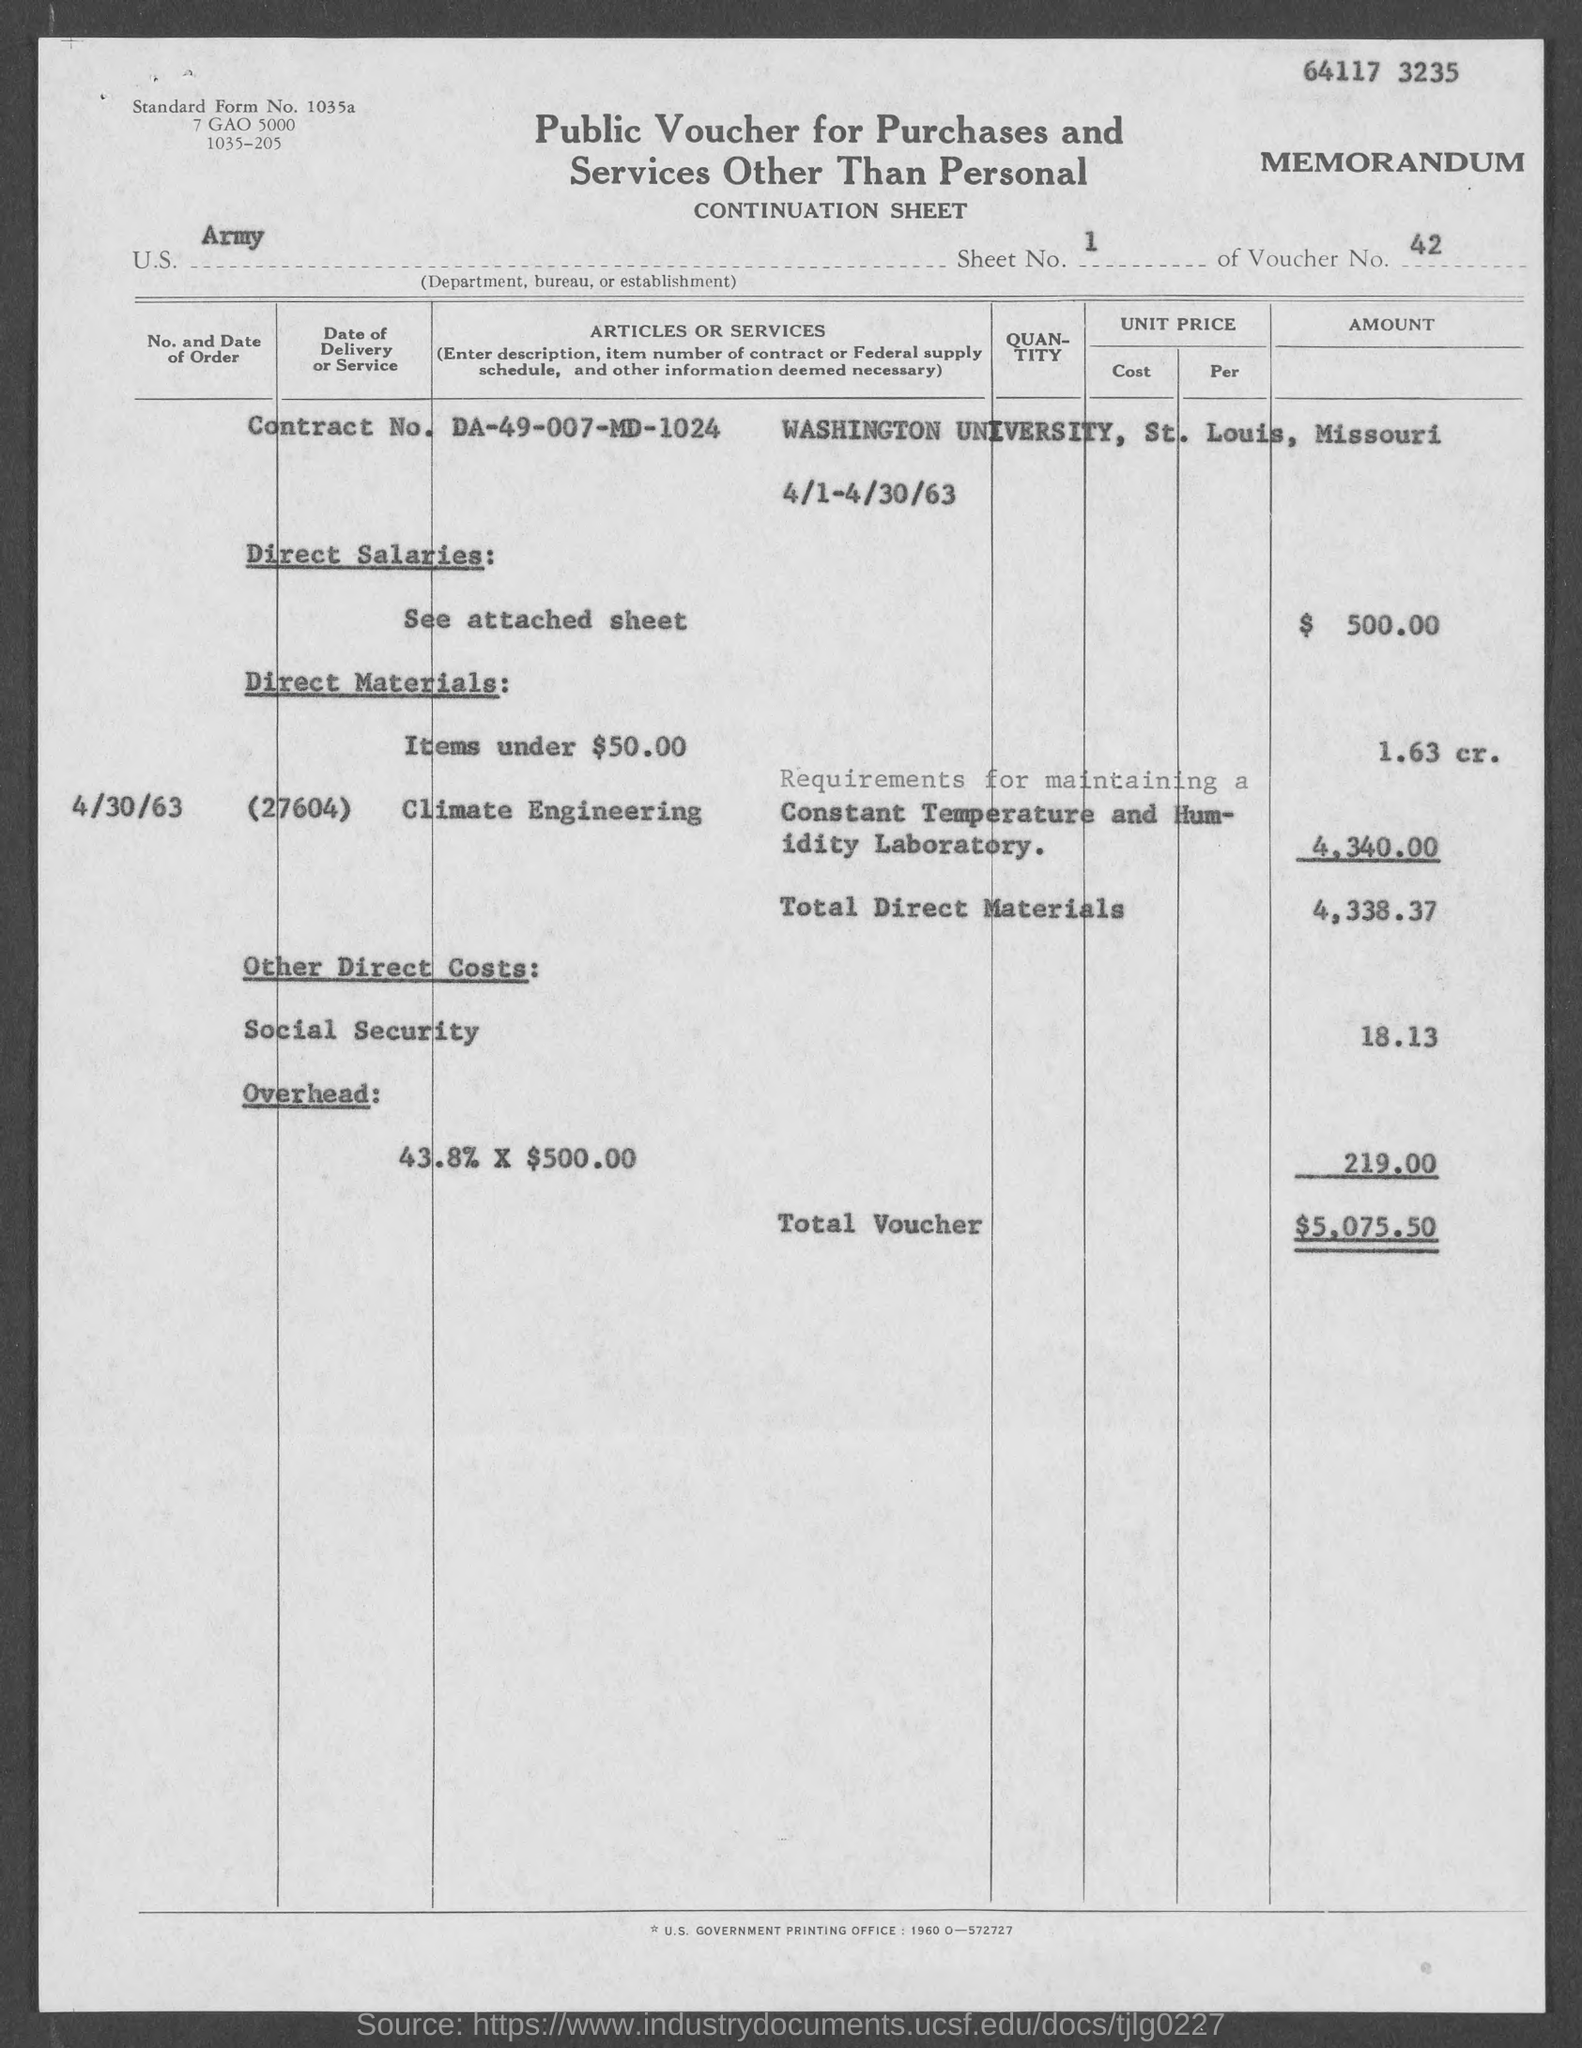Identify some key points in this picture. This document is titled 'Public Voucher for Purchases and Services Other Than Personal'. The total voucher is $5,075.50. The Contract No. is DA-49-007-MD-1024. The voucher number is 42. The direct salaries amount to $500.00. 